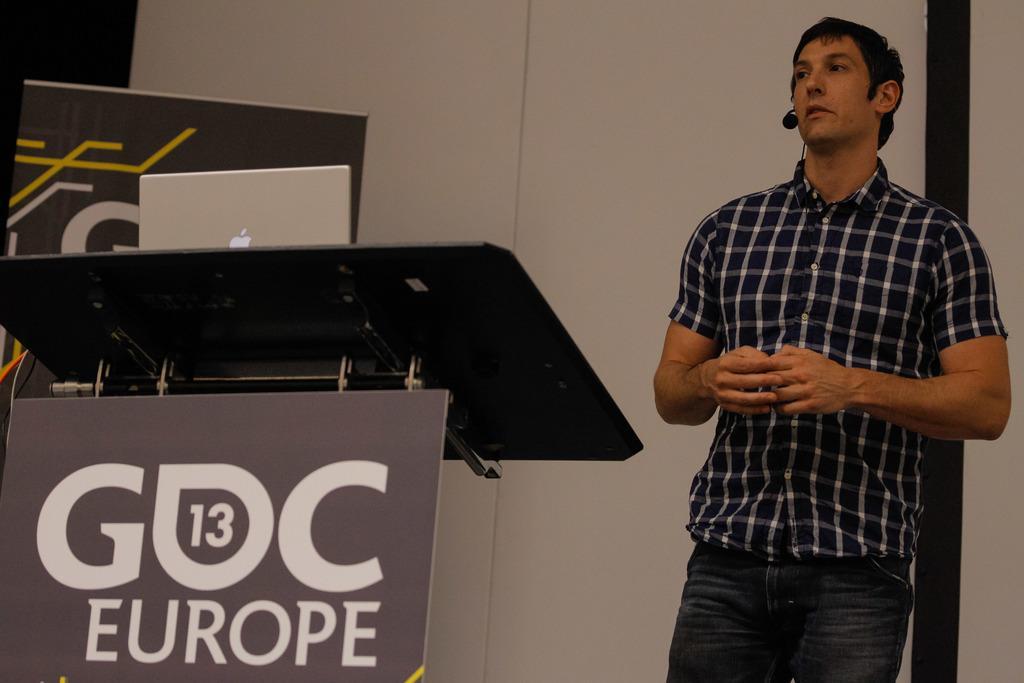In one or two sentences, can you explain what this image depicts? In this picture we can see one person is talking to the microphone, in front one table is placed on it one laptop is placed. 